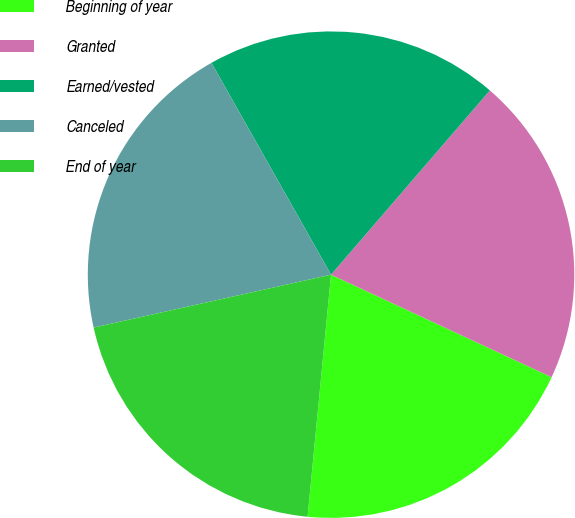Convert chart to OTSL. <chart><loc_0><loc_0><loc_500><loc_500><pie_chart><fcel>Beginning of year<fcel>Granted<fcel>Earned/vested<fcel>Canceled<fcel>End of year<nl><fcel>19.61%<fcel>20.6%<fcel>19.5%<fcel>20.31%<fcel>19.97%<nl></chart> 